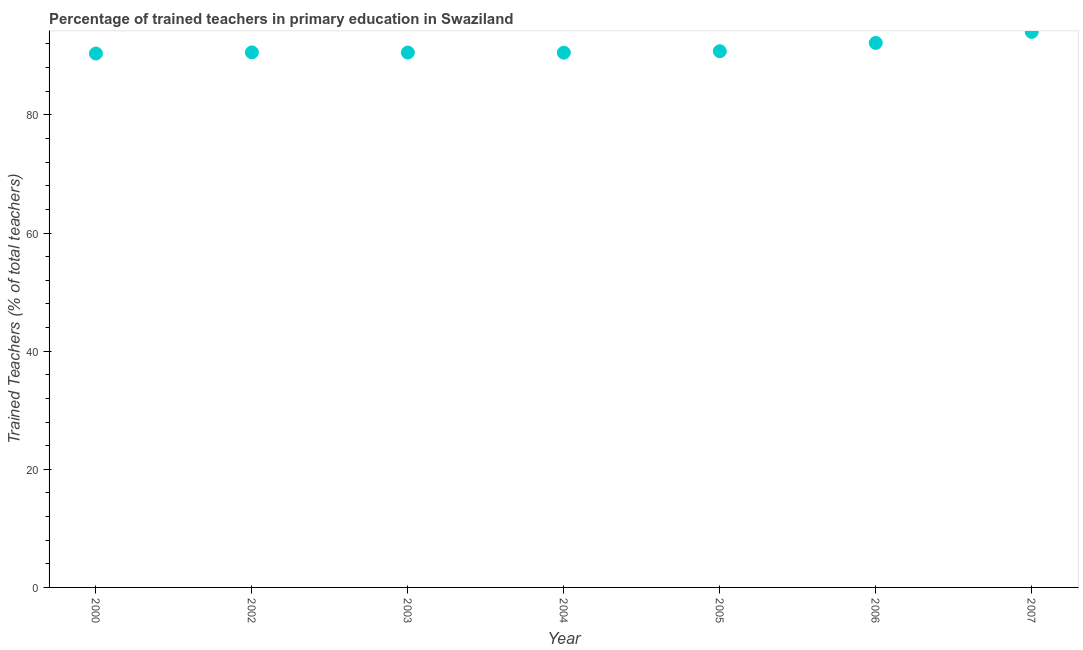What is the percentage of trained teachers in 2000?
Offer a terse response. 90.38. Across all years, what is the maximum percentage of trained teachers?
Ensure brevity in your answer.  94.04. Across all years, what is the minimum percentage of trained teachers?
Provide a succinct answer. 90.38. In which year was the percentage of trained teachers maximum?
Offer a very short reply. 2007. What is the sum of the percentage of trained teachers?
Keep it short and to the point. 639.04. What is the difference between the percentage of trained teachers in 2004 and 2006?
Provide a short and direct response. -1.65. What is the average percentage of trained teachers per year?
Your answer should be compact. 91.29. What is the median percentage of trained teachers?
Give a very brief answer. 90.58. In how many years, is the percentage of trained teachers greater than 32 %?
Provide a short and direct response. 7. Do a majority of the years between 2007 and 2003 (inclusive) have percentage of trained teachers greater than 40 %?
Make the answer very short. Yes. What is the ratio of the percentage of trained teachers in 2004 to that in 2006?
Give a very brief answer. 0.98. What is the difference between the highest and the second highest percentage of trained teachers?
Your answer should be very brief. 1.86. Is the sum of the percentage of trained teachers in 2006 and 2007 greater than the maximum percentage of trained teachers across all years?
Your response must be concise. Yes. What is the difference between the highest and the lowest percentage of trained teachers?
Offer a terse response. 3.66. In how many years, is the percentage of trained teachers greater than the average percentage of trained teachers taken over all years?
Your answer should be compact. 2. Does the percentage of trained teachers monotonically increase over the years?
Give a very brief answer. No. How many years are there in the graph?
Give a very brief answer. 7. Does the graph contain grids?
Provide a short and direct response. No. What is the title of the graph?
Your answer should be very brief. Percentage of trained teachers in primary education in Swaziland. What is the label or title of the X-axis?
Offer a very short reply. Year. What is the label or title of the Y-axis?
Your response must be concise. Trained Teachers (% of total teachers). What is the Trained Teachers (% of total teachers) in 2000?
Keep it short and to the point. 90.38. What is the Trained Teachers (% of total teachers) in 2002?
Your answer should be compact. 90.58. What is the Trained Teachers (% of total teachers) in 2003?
Ensure brevity in your answer.  90.55. What is the Trained Teachers (% of total teachers) in 2004?
Offer a very short reply. 90.53. What is the Trained Teachers (% of total teachers) in 2005?
Ensure brevity in your answer.  90.77. What is the Trained Teachers (% of total teachers) in 2006?
Your answer should be compact. 92.18. What is the Trained Teachers (% of total teachers) in 2007?
Your response must be concise. 94.04. What is the difference between the Trained Teachers (% of total teachers) in 2000 and 2002?
Make the answer very short. -0.19. What is the difference between the Trained Teachers (% of total teachers) in 2000 and 2003?
Give a very brief answer. -0.17. What is the difference between the Trained Teachers (% of total teachers) in 2000 and 2004?
Your response must be concise. -0.15. What is the difference between the Trained Teachers (% of total teachers) in 2000 and 2005?
Your answer should be compact. -0.39. What is the difference between the Trained Teachers (% of total teachers) in 2000 and 2006?
Your response must be concise. -1.8. What is the difference between the Trained Teachers (% of total teachers) in 2000 and 2007?
Give a very brief answer. -3.66. What is the difference between the Trained Teachers (% of total teachers) in 2002 and 2003?
Make the answer very short. 0.02. What is the difference between the Trained Teachers (% of total teachers) in 2002 and 2004?
Your response must be concise. 0.05. What is the difference between the Trained Teachers (% of total teachers) in 2002 and 2005?
Ensure brevity in your answer.  -0.2. What is the difference between the Trained Teachers (% of total teachers) in 2002 and 2006?
Offer a very short reply. -1.61. What is the difference between the Trained Teachers (% of total teachers) in 2002 and 2007?
Keep it short and to the point. -3.47. What is the difference between the Trained Teachers (% of total teachers) in 2003 and 2004?
Your answer should be compact. 0.02. What is the difference between the Trained Teachers (% of total teachers) in 2003 and 2005?
Ensure brevity in your answer.  -0.22. What is the difference between the Trained Teachers (% of total teachers) in 2003 and 2006?
Your answer should be compact. -1.63. What is the difference between the Trained Teachers (% of total teachers) in 2003 and 2007?
Your answer should be very brief. -3.49. What is the difference between the Trained Teachers (% of total teachers) in 2004 and 2005?
Provide a short and direct response. -0.24. What is the difference between the Trained Teachers (% of total teachers) in 2004 and 2006?
Your answer should be compact. -1.65. What is the difference between the Trained Teachers (% of total teachers) in 2004 and 2007?
Make the answer very short. -3.51. What is the difference between the Trained Teachers (% of total teachers) in 2005 and 2006?
Provide a short and direct response. -1.41. What is the difference between the Trained Teachers (% of total teachers) in 2005 and 2007?
Your answer should be compact. -3.27. What is the difference between the Trained Teachers (% of total teachers) in 2006 and 2007?
Make the answer very short. -1.86. What is the ratio of the Trained Teachers (% of total teachers) in 2002 to that in 2005?
Make the answer very short. 1. What is the ratio of the Trained Teachers (% of total teachers) in 2003 to that in 2004?
Provide a short and direct response. 1. What is the ratio of the Trained Teachers (% of total teachers) in 2003 to that in 2006?
Provide a succinct answer. 0.98. What is the ratio of the Trained Teachers (% of total teachers) in 2003 to that in 2007?
Your answer should be compact. 0.96. What is the ratio of the Trained Teachers (% of total teachers) in 2004 to that in 2006?
Offer a very short reply. 0.98. What is the ratio of the Trained Teachers (% of total teachers) in 2005 to that in 2006?
Provide a short and direct response. 0.98. 